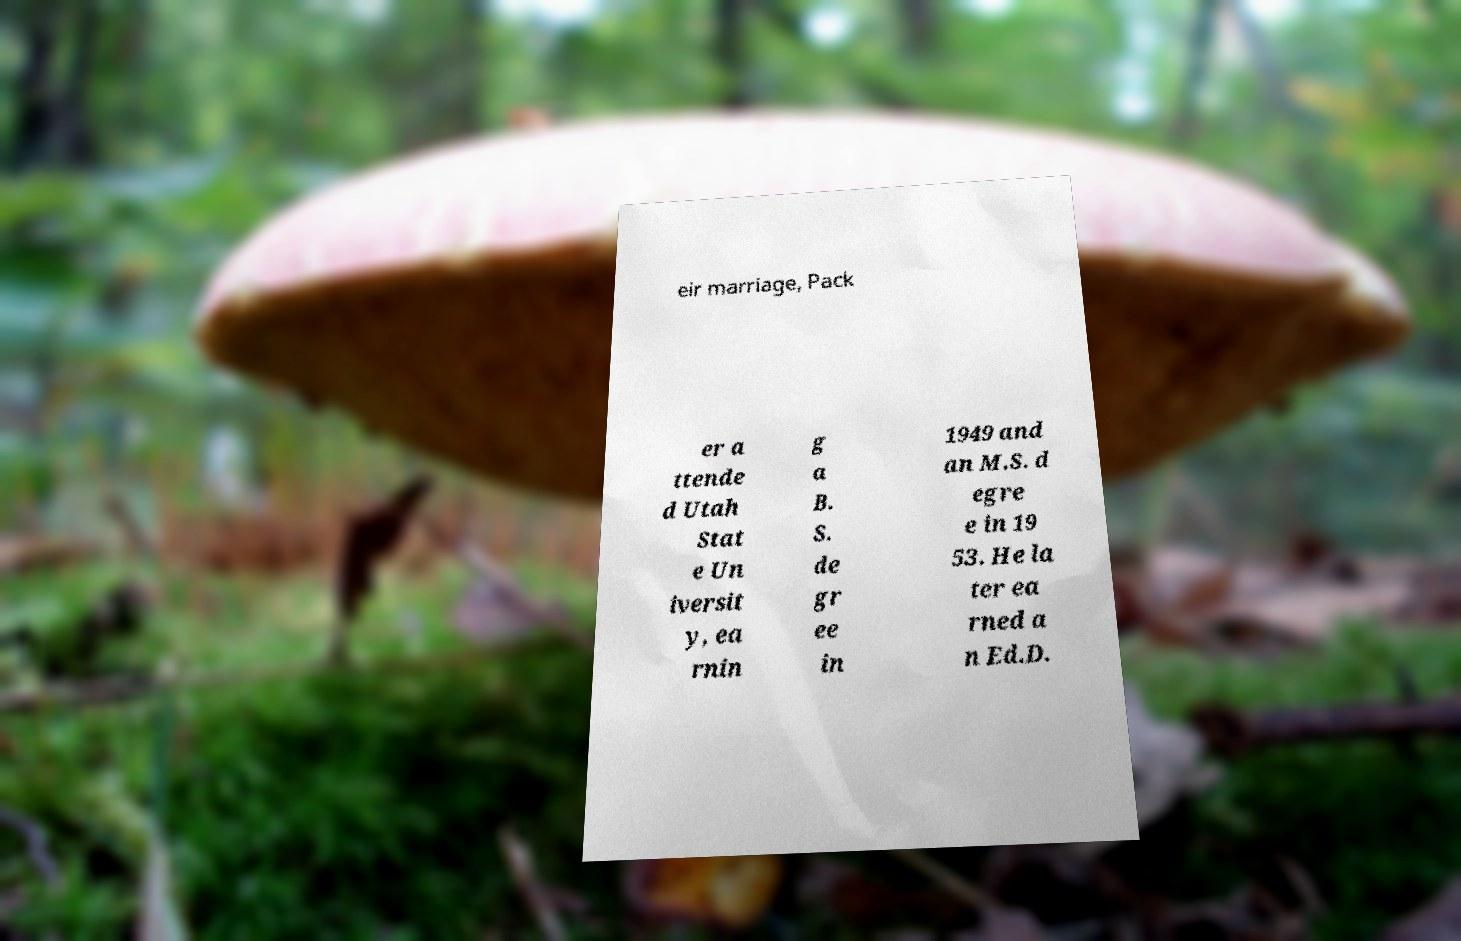Could you assist in decoding the text presented in this image and type it out clearly? eir marriage, Pack er a ttende d Utah Stat e Un iversit y, ea rnin g a B. S. de gr ee in 1949 and an M.S. d egre e in 19 53. He la ter ea rned a n Ed.D. 